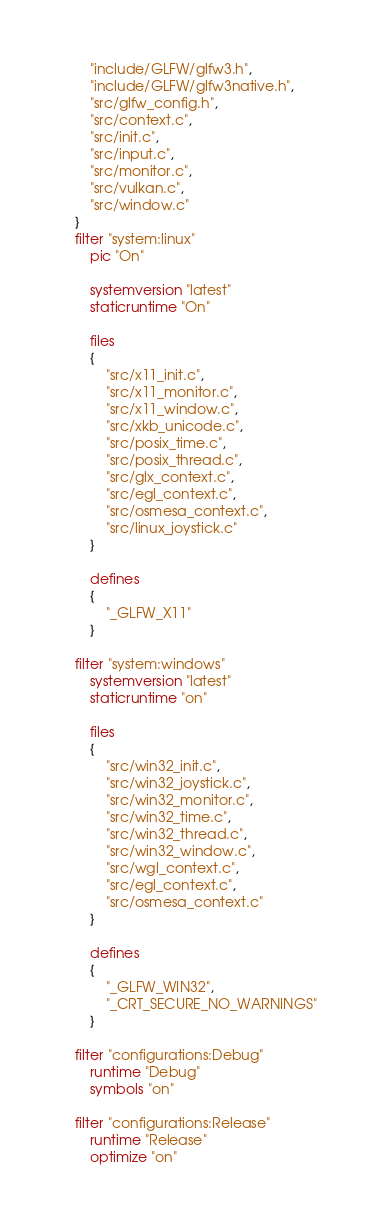Convert code to text. <code><loc_0><loc_0><loc_500><loc_500><_Lua_>		"include/GLFW/glfw3.h",
		"include/GLFW/glfw3native.h",
		"src/glfw_config.h",
		"src/context.c",
		"src/init.c",
		"src/input.c",
		"src/monitor.c",
		"src/vulkan.c",
		"src/window.c"
	}
	filter "system:linux"
		pic "On"

		systemversion "latest"
		staticruntime "On"

		files
		{
			"src/x11_init.c",
			"src/x11_monitor.c",
			"src/x11_window.c",
			"src/xkb_unicode.c",
			"src/posix_time.c",
			"src/posix_thread.c",
			"src/glx_context.c",
			"src/egl_context.c",
			"src/osmesa_context.c",
			"src/linux_joystick.c"
		}

		defines
		{
			"_GLFW_X11"
		}

	filter "system:windows"
		systemversion "latest"
		staticruntime "on"

		files
		{
			"src/win32_init.c",
			"src/win32_joystick.c",
			"src/win32_monitor.c",
			"src/win32_time.c",
			"src/win32_thread.c",
			"src/win32_window.c",
			"src/wgl_context.c",
			"src/egl_context.c",
			"src/osmesa_context.c"
		}

		defines 
		{ 
			"_GLFW_WIN32",
			"_CRT_SECURE_NO_WARNINGS"
		}

	filter "configurations:Debug"
		runtime "Debug"
		symbols "on"

	filter "configurations:Release"
		runtime "Release"
		optimize "on"</code> 